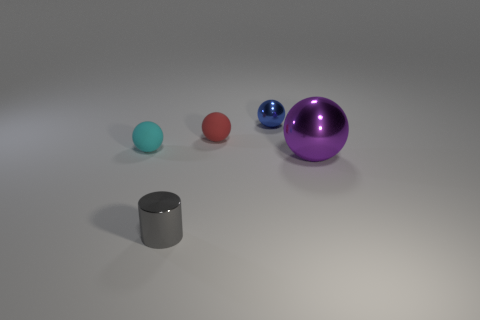Add 4 metallic cylinders. How many objects exist? 9 Subtract all spheres. How many objects are left? 1 Add 4 tiny objects. How many tiny objects exist? 8 Subtract 0 red cylinders. How many objects are left? 5 Subtract all cyan matte objects. Subtract all tiny red objects. How many objects are left? 3 Add 4 tiny gray metallic objects. How many tiny gray metallic objects are left? 5 